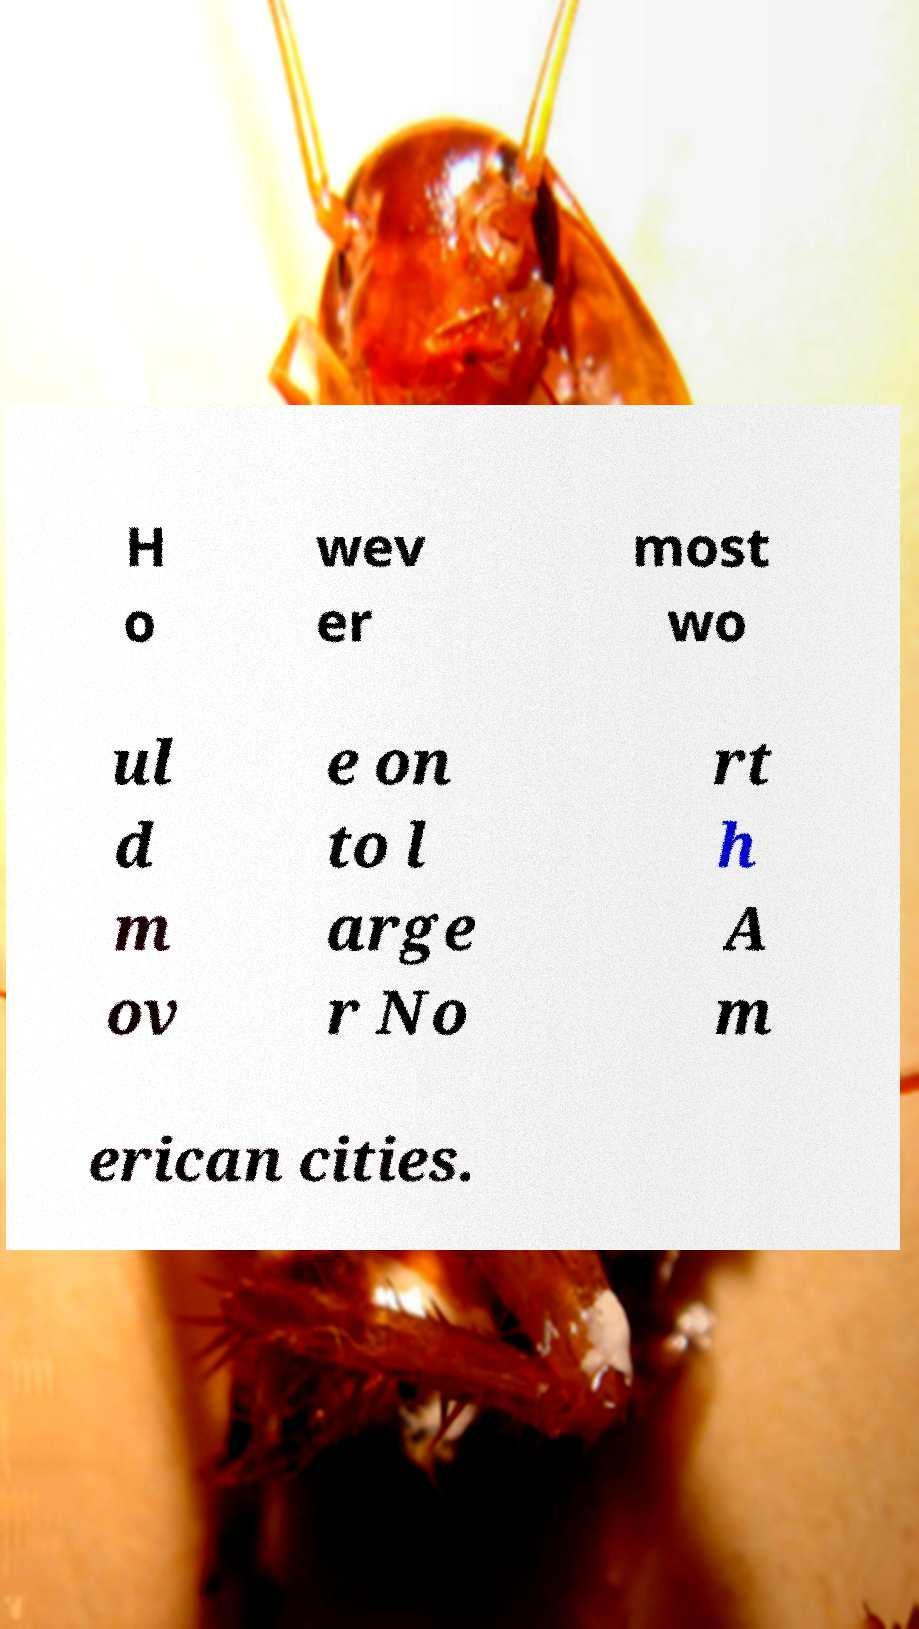Could you assist in decoding the text presented in this image and type it out clearly? H o wev er most wo ul d m ov e on to l arge r No rt h A m erican cities. 